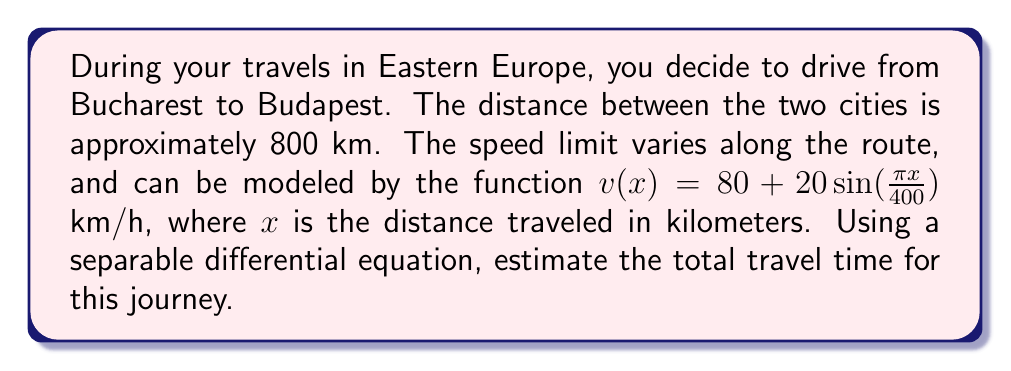What is the answer to this math problem? Let's approach this problem step-by-step using a separable differential equation:

1) First, we need to set up our differential equation. We know that velocity is the rate of change of distance with respect to time:

   $v = \frac{dx}{dt}$

2) We're given the velocity as a function of distance:

   $v(x) = 80 + 20\sin(\frac{\pi x}{400})$

3) Substituting this into our differential equation:

   $80 + 20\sin(\frac{\pi x}{400}) = \frac{dx}{dt}$

4) Rearranging this to get our separable form:

   $dt = \frac{dx}{80 + 20\sin(\frac{\pi x}{400})}$

5) To find the total time, we need to integrate both sides from 0 to 800 km:

   $\int_0^T dt = \int_0^{800} \frac{dx}{80 + 20\sin(\frac{\pi x}{400})}$

   Where T is the total time we're trying to find.

6) The left side integrates simply to T. The right side doesn't have an elementary antiderivative, so we'll need to use numerical integration. Let's call the integral I:

   $T = I = \int_0^{800} \frac{dx}{80 + 20\sin(\frac{\pi x}{400})}$

7) Using a numerical integration method (like Simpson's rule or a computer algebra system), we can evaluate this integral:

   $I \approx 9.97$ hours

Therefore, the estimated travel time is approximately 9.97 hours.
Answer: The estimated travel time from Bucharest to Budapest, considering the varying speed limits, is approximately 9.97 hours. 